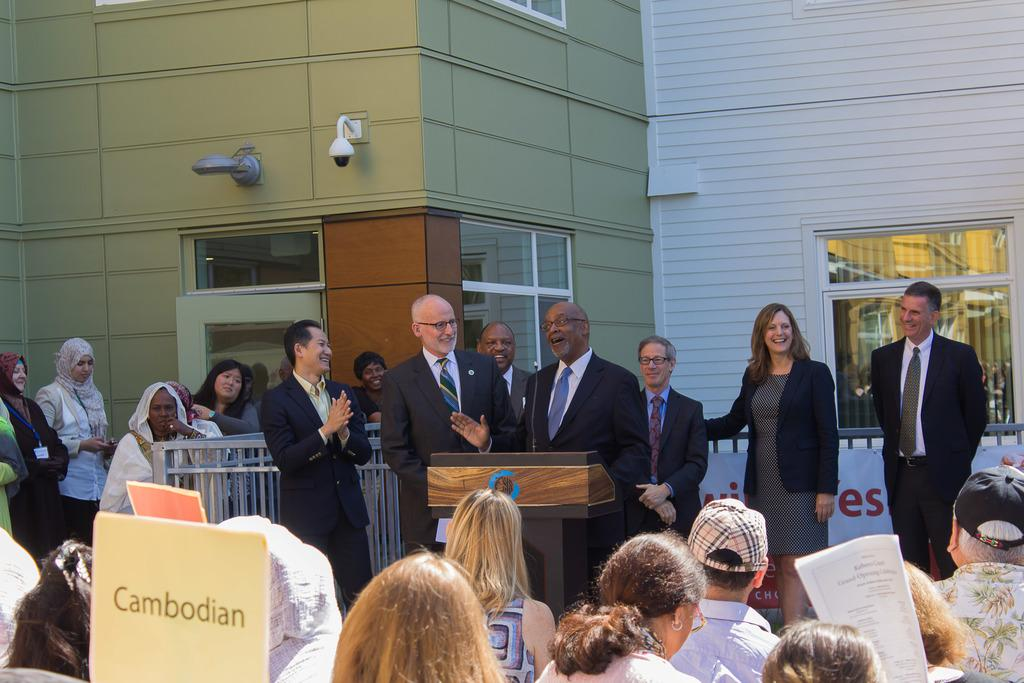What is located in the background of the image? There are persons in front of the building in the image. What type of barrier is present in the image? There is a metal fence in the image. What object can be seen at the bottom of the image? There is a podium at the bottom of the image. Where is the placard located in the image? The placard is in the bottom left of the image. What decision was made by the board in the image? There is no board or decision-making process depicted in the image. What type of neck accessory is worn by the persons in the image? There is no information about neck accessories worn by the persons in the image. 